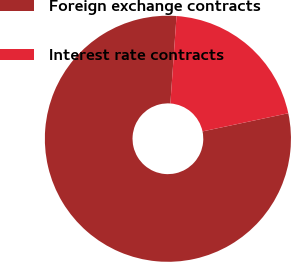<chart> <loc_0><loc_0><loc_500><loc_500><pie_chart><fcel>Foreign exchange contracts<fcel>Interest rate contracts<nl><fcel>79.44%<fcel>20.56%<nl></chart> 